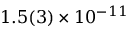<formula> <loc_0><loc_0><loc_500><loc_500>1 . 5 ( 3 ) \times 1 0 ^ { - 1 1 }</formula> 